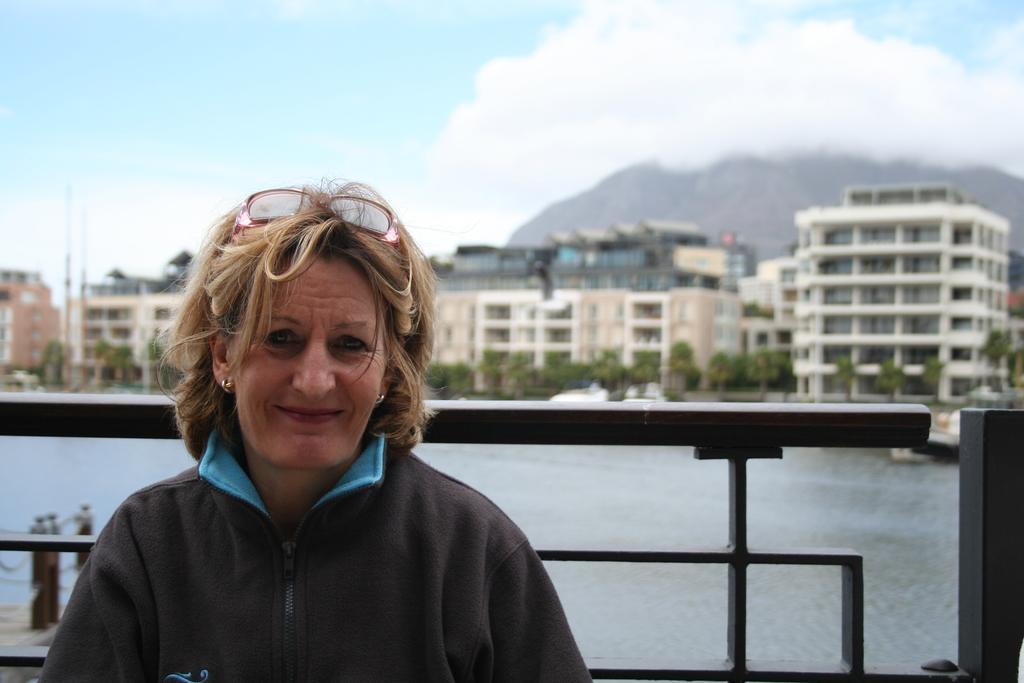How would you summarize this image in a sentence or two? In this picture there is a woman smiling. At the back there is a railing and there are buildings and trees and their might be a mountain. At top there is sky and there are clouds. At the bottom there are boats on the water. 